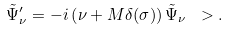<formula> <loc_0><loc_0><loc_500><loc_500>\tilde { \Psi } ^ { \prime } _ { \nu } = - i \left ( \nu + { M } \delta ( \sigma ) \right ) \tilde { \Psi } _ { \nu } \ > .</formula> 